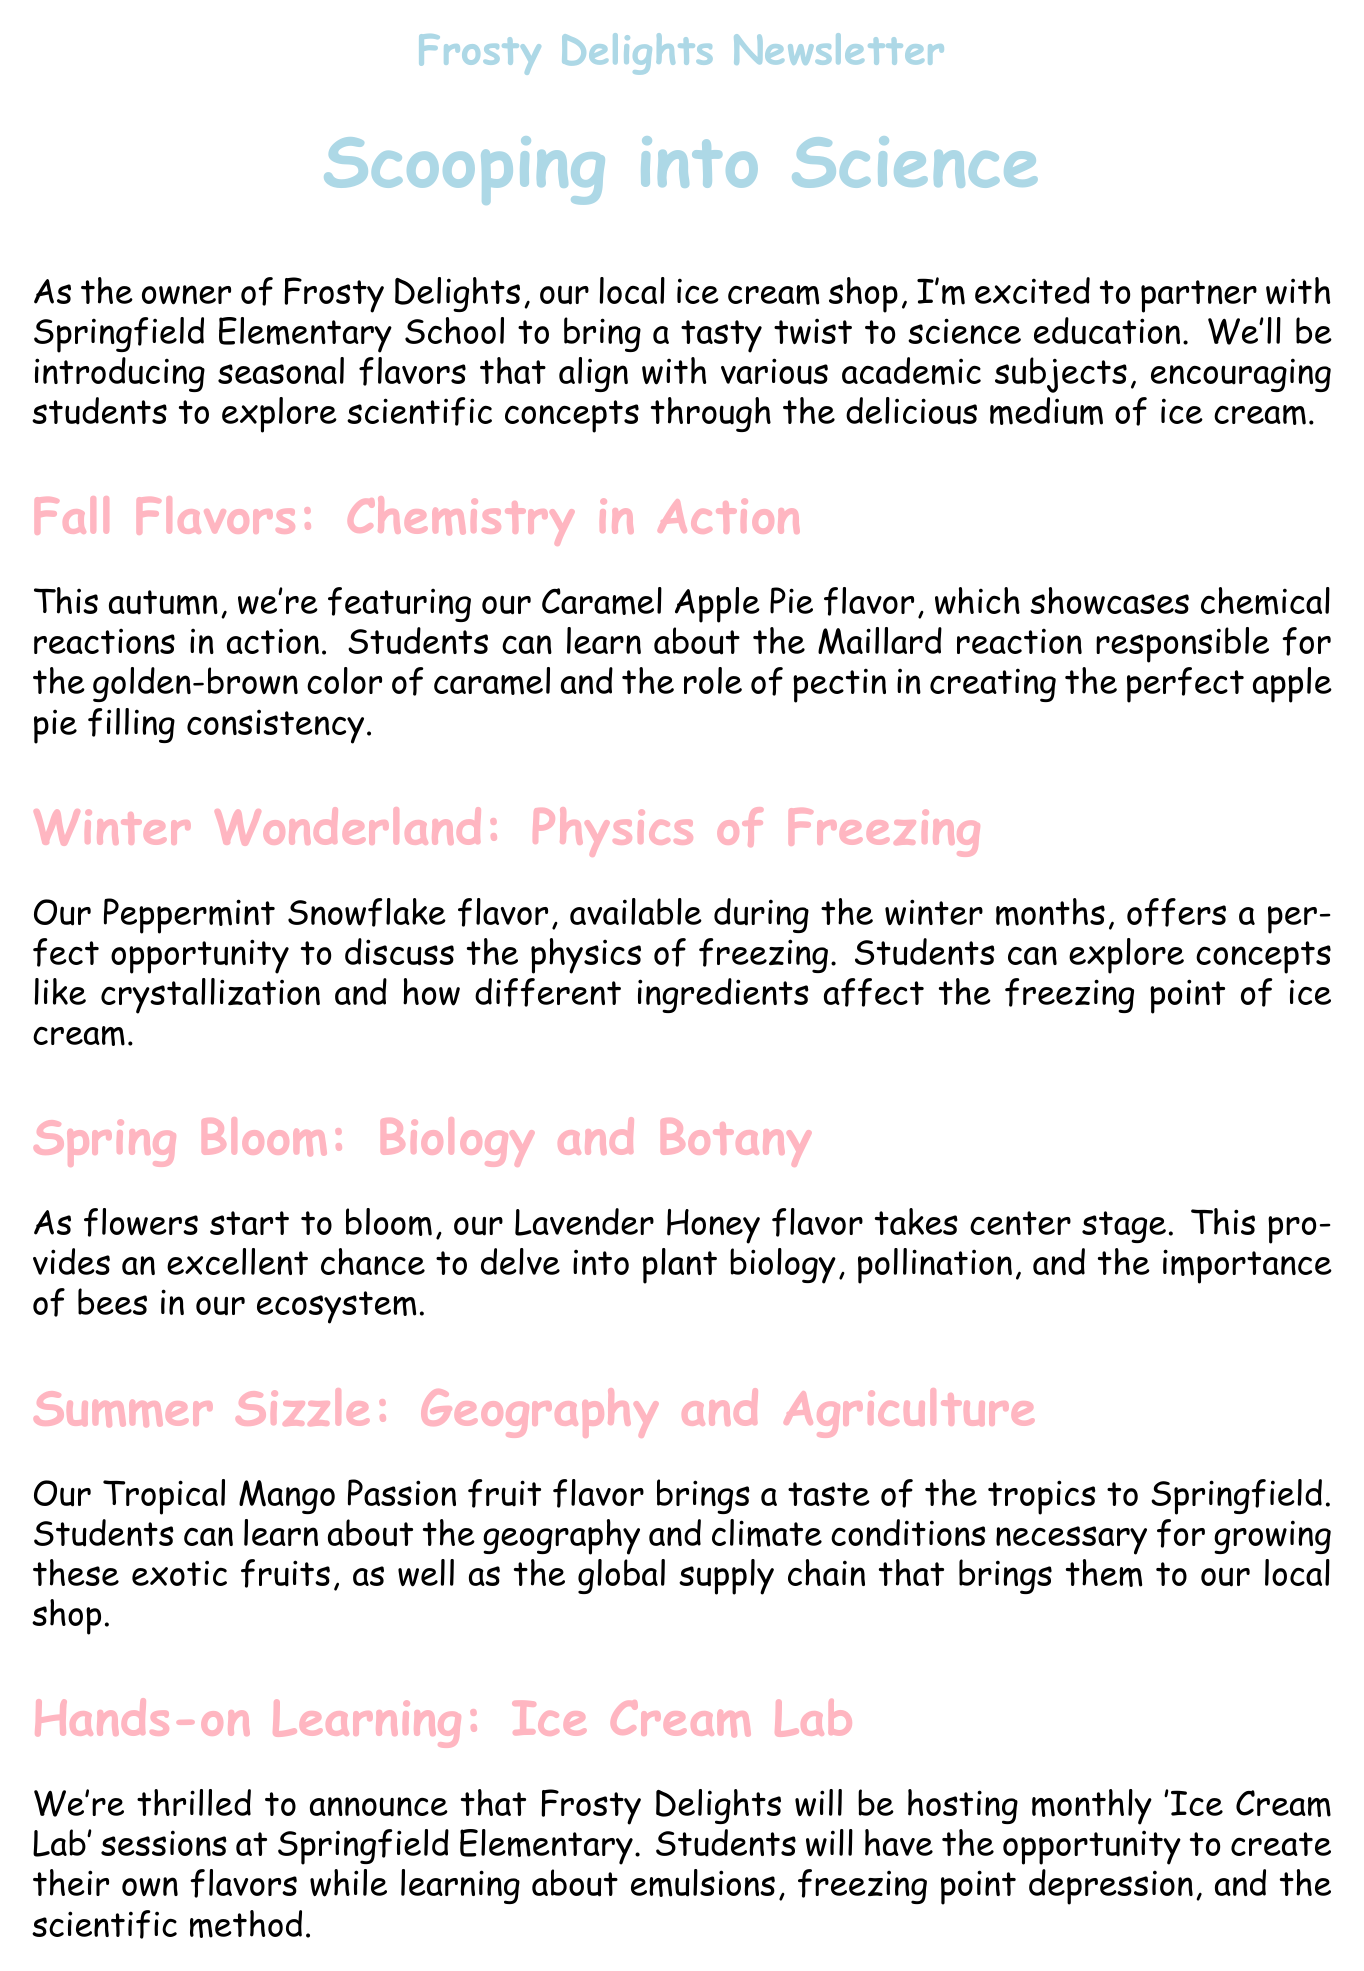What is the main topic of the newsletter? The newsletter's main topic discusses seasonal flavors of ice cream and their connection to science education.
Answer: Seasonal flavors and science education What flavor represents the fall season? The document specifies the seasonal flavor for fall as Caramel Apple Pie.
Answer: Caramel Apple Pie What scientific concept is explored with the Peppermint Snowflake flavor? The Peppermint Snowflake flavor is associated with the physics of freezing.
Answer: Physics of freezing Which flower flavor is highlighted in the spring section? Lavender Honey is the flavor that takes center stage in the spring section.
Answer: Lavender Honey What monthly event will Frosty Delights host? Frosty Delights will host monthly "Ice Cream Lab" sessions.
Answer: Ice Cream Lab What is the purpose of the Community Scoop Challenge? The challenge invites students to submit flavor ideas based on scientific concepts, with proceeds supporting the school's science program.
Answer: Support school science program How can parents continue the learning at home? Parents can access resources provided by the American Chemical Society on the newsletter's website.
Answer: American Chemical Society resources What is the website mentioned in the newsletter? The newsletter provides a website for parents to visit for additional resources.
Answer: www.frostydelights.com/sciencescoops 